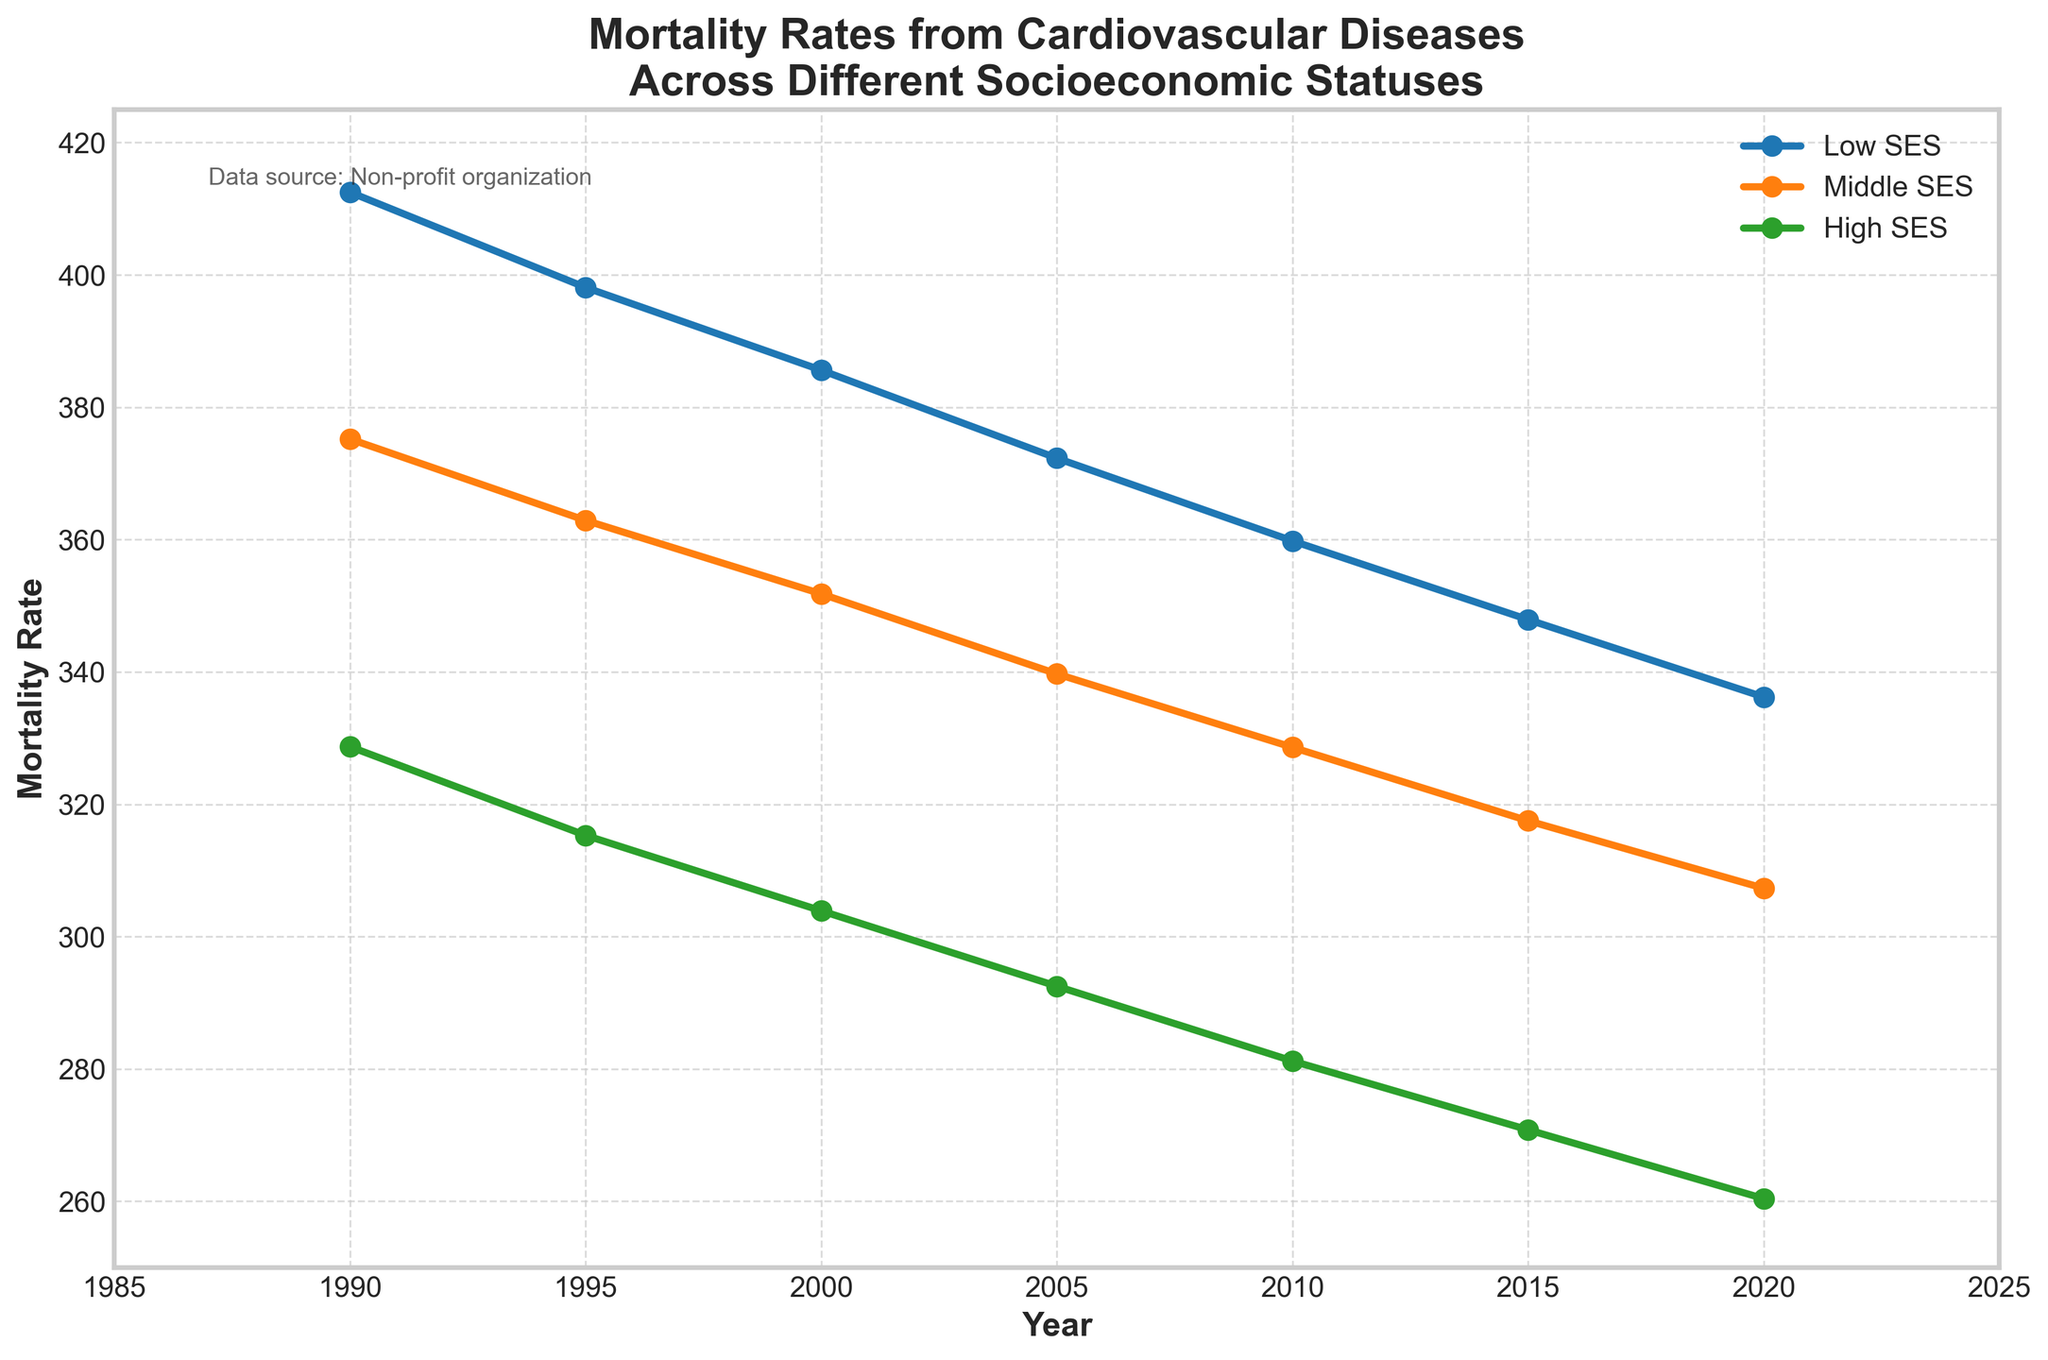What is the overall trend in mortality rates from cardiovascular diseases across all socioeconomic statuses from 1990 to 2020? Observe the lines for Low SES, Middle SES, and High SES all decrease steadily over time on the chart. This indicates a consistent downward trend.
Answer: Decreasing By how much did the mortality rate for Low SES decrease from 1990 to 2020? Locate the Low SES line and check the mortality rates at 1990 (412.5) and 2020 (336.2). Subtract the rate in 2020 from the rate in 1990: 412.5 - 336.2 = 76.3.
Answer: 76.3 Which socioeconomic status group had the highest mortality rate in 2010? Look at the mortality rate values for 2010 on the x-axis for Low SES, Middle SES, and High SES groups. Identify the highest value among them, which is 359.8 for Low SES.
Answer: Low SES How does the mortality rate gap between Low SES and High SES change from 1990 to 2020? Calculate the difference in mortality rates for Low SES and High SES in 1990 (412.5 - 328.7 = 83.8) and in 2020 (336.2 - 260.4 = 75.8). Compare the gaps: 83.8 - 75.8 = 8.
Answer: Decrease by 8 Which year recorded the smallest difference in mortality rates between Middle SES and High SES? Calculate the differences for each year by subtracting High SES values from Middle SES values:
(1990: 375.2 - 328.7 = 46.5; 1995: 362.9 - 315.3 = 47.6; 2000: 351.8 - 303.9 = 47.9; 2005: 339.7 - 292.5 = 47.2; 2010: 328.6 - 281.2 = 47.4; 2015: 317.5 - 270.8 = 46.7; 2020: 307.3 - 260.4 = 46.9). The smallest difference is in 1990.
Answer: 1990 From 1990 to 2020, in which year did the High SES group experience the largest single year-over-year reduction in mortality rates? Examine the High SES line's yearly values and calculate the yearly differences:
(1990-1995: 328.7 - 315.3 = 13.4; 1995-2000: 315.3 - 303.9 = 11.4; 2000-2005: 303.9 - 292.5 = 11.4; 2005-2010: 292.5 - 281.2 = 11.3; 2010-2015: 281.2 - 270.8 = 10.4; 2015-2020: 270.8 - 260.4 = 10.4). The largest reduction is 13.4 from 1990 to 1995.
Answer: 1990-1995 On average, how much did the Middle SES mortality rate decrease every 5 years over the 30-year period? Calculate the overall decrease from 1990 (375.2) to 2020 (307.3): 375.2 - 307.3 = 67.9. Then, divide this by the number of 5-year periods within 30 years (6): 67.9 / 6 = 11.32.
Answer: 11.32 What data source is mentioned on the chart? Refer to the text box on the chart noting the data source: "Data source: Non-profit organization."
Answer: Non-profit organization 